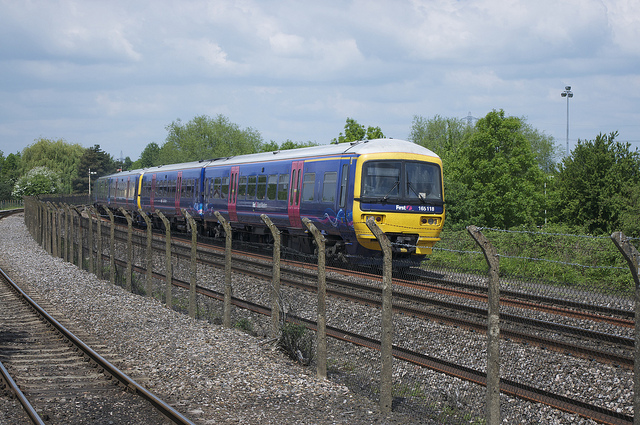<image>How many train cars are there? I am not sure how many train cars there are. It could be 2, 3, or 4. How many train cars are there? It is unknown how many train cars are there. It can be seen either 3 or 4. 